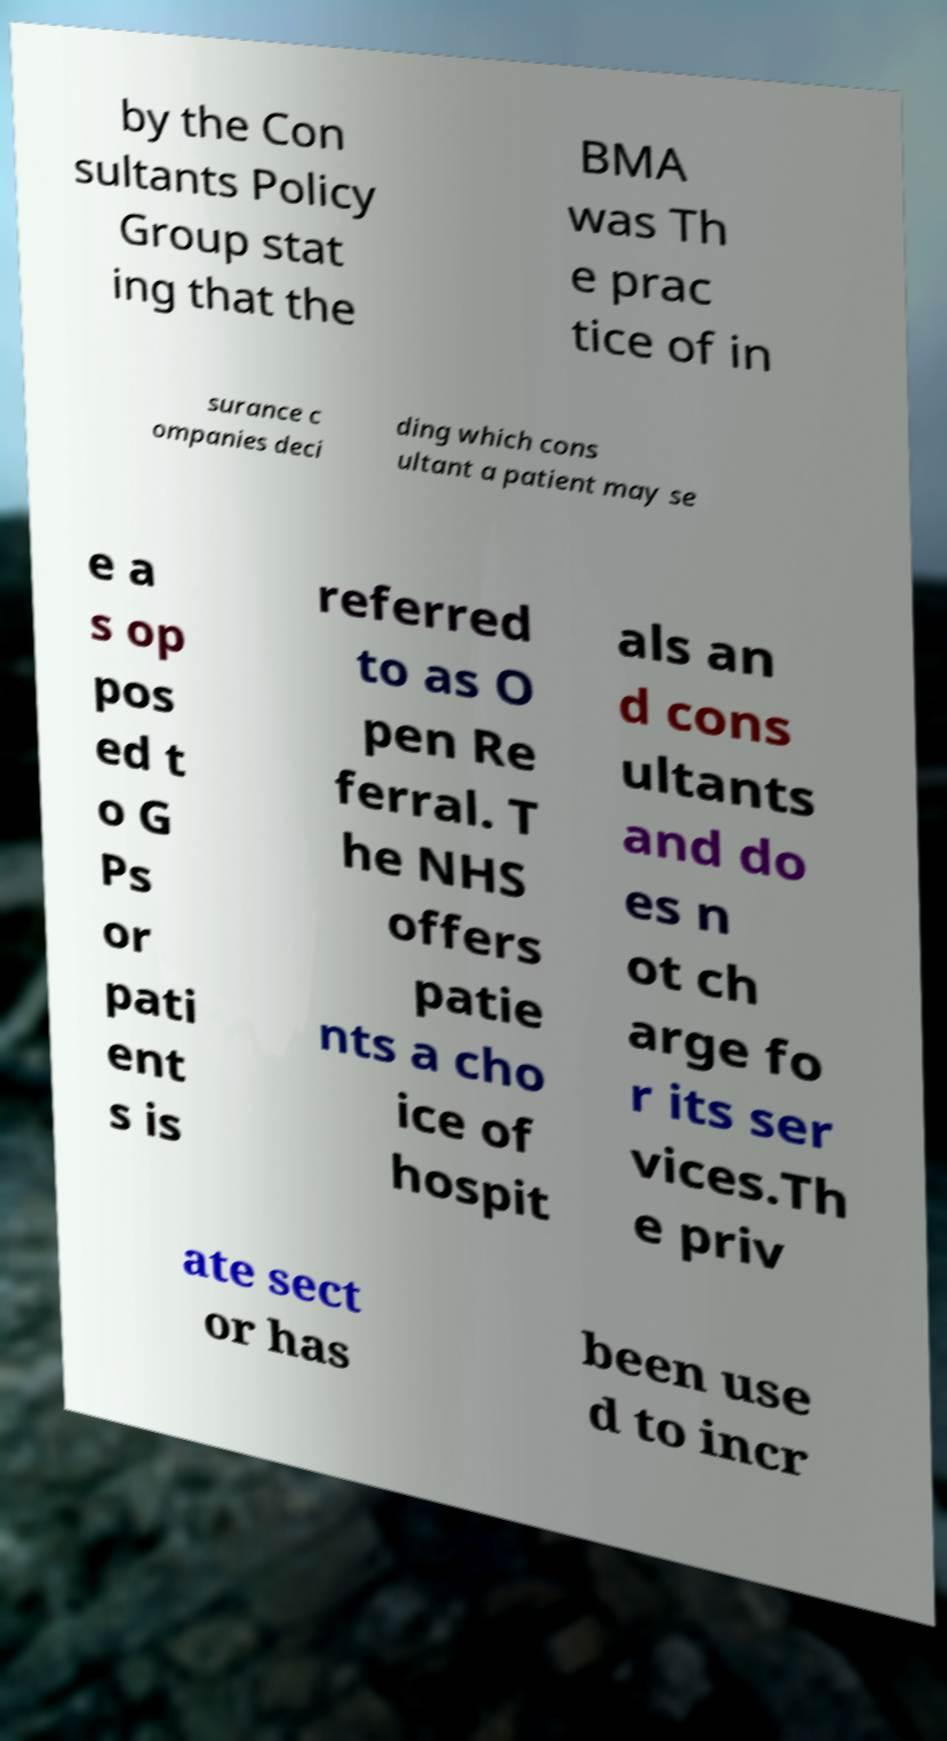Please identify and transcribe the text found in this image. by the Con sultants Policy Group stat ing that the BMA was Th e prac tice of in surance c ompanies deci ding which cons ultant a patient may se e a s op pos ed t o G Ps or pati ent s is referred to as O pen Re ferral. T he NHS offers patie nts a cho ice of hospit als an d cons ultants and do es n ot ch arge fo r its ser vices.Th e priv ate sect or has been use d to incr 